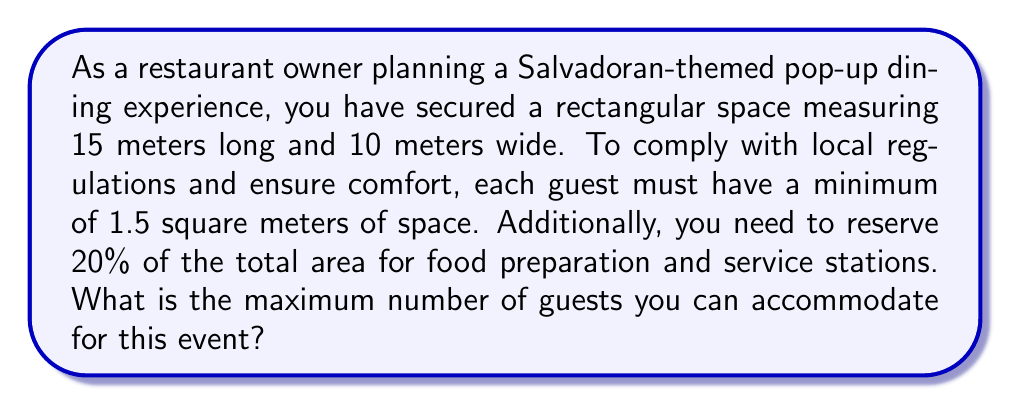Show me your answer to this math problem. Let's approach this problem step by step:

1. Calculate the total area of the space:
   $$\text{Total Area} = \text{Length} \times \text{Width} = 15 \text{ m} \times 10 \text{ m} = 150 \text{ m}^2$$

2. Calculate the area reserved for food preparation and service (20% of total):
   $$\text{Reserved Area} = 20\% \times 150 \text{ m}^2 = 0.2 \times 150 \text{ m}^2 = 30 \text{ m}^2$$

3. Calculate the remaining area for guests:
   $$\text{Guest Area} = \text{Total Area} - \text{Reserved Area} = 150 \text{ m}^2 - 30 \text{ m}^2 = 120 \text{ m}^2$$

4. Calculate the maximum number of guests:
   $$\text{Max Guests} = \left\lfloor\frac{\text{Guest Area}}{\text{Area per Guest}}\right\rfloor = \left\lfloor\frac{120 \text{ m}^2}{1.5 \text{ m}^2}\right\rfloor = \left\lfloor80\right\rfloor = 80$$

   Note: We use the floor function $\left\lfloor \right\rfloor$ to round down to the nearest whole number, as we can't accommodate fractional guests.

Therefore, the maximum number of guests that can be accommodated is 80.
Answer: 80 guests 